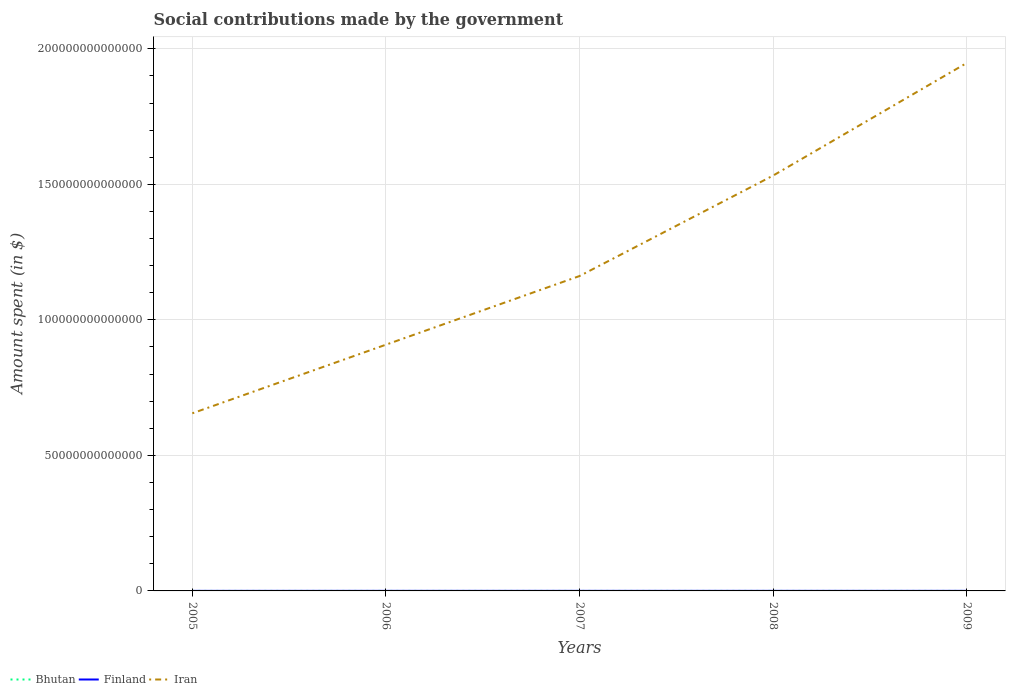Does the line corresponding to Finland intersect with the line corresponding to Iran?
Your answer should be very brief. No. Across all years, what is the maximum amount spent on social contributions in Bhutan?
Offer a very short reply. 3.60e+07. In which year was the amount spent on social contributions in Bhutan maximum?
Offer a very short reply. 2005. What is the total amount spent on social contributions in Bhutan in the graph?
Your answer should be compact. -2.72e+07. What is the difference between the highest and the second highest amount spent on social contributions in Bhutan?
Your response must be concise. 3.53e+07. What is the difference between the highest and the lowest amount spent on social contributions in Finland?
Ensure brevity in your answer.  3. How many lines are there?
Offer a terse response. 3. How many years are there in the graph?
Your answer should be compact. 5. What is the difference between two consecutive major ticks on the Y-axis?
Your answer should be very brief. 5.00e+13. Does the graph contain grids?
Your answer should be very brief. Yes. Where does the legend appear in the graph?
Provide a short and direct response. Bottom left. How are the legend labels stacked?
Make the answer very short. Horizontal. What is the title of the graph?
Make the answer very short. Social contributions made by the government. What is the label or title of the Y-axis?
Your answer should be very brief. Amount spent (in $). What is the Amount spent (in $) in Bhutan in 2005?
Ensure brevity in your answer.  3.60e+07. What is the Amount spent (in $) in Finland in 2005?
Keep it short and to the point. 1.91e+1. What is the Amount spent (in $) of Iran in 2005?
Make the answer very short. 6.55e+13. What is the Amount spent (in $) in Bhutan in 2006?
Give a very brief answer. 4.41e+07. What is the Amount spent (in $) of Finland in 2006?
Ensure brevity in your answer.  2.05e+1. What is the Amount spent (in $) of Iran in 2006?
Keep it short and to the point. 9.09e+13. What is the Amount spent (in $) in Bhutan in 2007?
Give a very brief answer. 4.94e+07. What is the Amount spent (in $) of Finland in 2007?
Keep it short and to the point. 2.16e+1. What is the Amount spent (in $) of Iran in 2007?
Your answer should be compact. 1.16e+14. What is the Amount spent (in $) in Bhutan in 2008?
Offer a very short reply. 5.82e+07. What is the Amount spent (in $) in Finland in 2008?
Give a very brief answer. 2.25e+1. What is the Amount spent (in $) in Iran in 2008?
Provide a short and direct response. 1.53e+14. What is the Amount spent (in $) of Bhutan in 2009?
Provide a succinct answer. 7.13e+07. What is the Amount spent (in $) in Finland in 2009?
Your response must be concise. 2.22e+1. What is the Amount spent (in $) of Iran in 2009?
Give a very brief answer. 1.95e+14. Across all years, what is the maximum Amount spent (in $) of Bhutan?
Provide a succinct answer. 7.13e+07. Across all years, what is the maximum Amount spent (in $) of Finland?
Offer a terse response. 2.25e+1. Across all years, what is the maximum Amount spent (in $) of Iran?
Your answer should be compact. 1.95e+14. Across all years, what is the minimum Amount spent (in $) in Bhutan?
Provide a succinct answer. 3.60e+07. Across all years, what is the minimum Amount spent (in $) in Finland?
Ensure brevity in your answer.  1.91e+1. Across all years, what is the minimum Amount spent (in $) in Iran?
Keep it short and to the point. 6.55e+13. What is the total Amount spent (in $) in Bhutan in the graph?
Your answer should be very brief. 2.59e+08. What is the total Amount spent (in $) in Finland in the graph?
Give a very brief answer. 1.06e+11. What is the total Amount spent (in $) of Iran in the graph?
Make the answer very short. 6.21e+14. What is the difference between the Amount spent (in $) of Bhutan in 2005 and that in 2006?
Provide a succinct answer. -8.06e+06. What is the difference between the Amount spent (in $) in Finland in 2005 and that in 2006?
Your answer should be very brief. -1.39e+09. What is the difference between the Amount spent (in $) of Iran in 2005 and that in 2006?
Your answer should be compact. -2.53e+13. What is the difference between the Amount spent (in $) of Bhutan in 2005 and that in 2007?
Keep it short and to the point. -1.34e+07. What is the difference between the Amount spent (in $) of Finland in 2005 and that in 2007?
Offer a terse response. -2.50e+09. What is the difference between the Amount spent (in $) in Iran in 2005 and that in 2007?
Offer a very short reply. -5.06e+13. What is the difference between the Amount spent (in $) in Bhutan in 2005 and that in 2008?
Your answer should be very brief. -2.22e+07. What is the difference between the Amount spent (in $) of Finland in 2005 and that in 2008?
Your answer should be compact. -3.45e+09. What is the difference between the Amount spent (in $) in Iran in 2005 and that in 2008?
Your response must be concise. -8.77e+13. What is the difference between the Amount spent (in $) of Bhutan in 2005 and that in 2009?
Make the answer very short. -3.53e+07. What is the difference between the Amount spent (in $) in Finland in 2005 and that in 2009?
Offer a very short reply. -3.15e+09. What is the difference between the Amount spent (in $) of Iran in 2005 and that in 2009?
Offer a terse response. -1.29e+14. What is the difference between the Amount spent (in $) of Bhutan in 2006 and that in 2007?
Your response must be concise. -5.36e+06. What is the difference between the Amount spent (in $) in Finland in 2006 and that in 2007?
Provide a succinct answer. -1.11e+09. What is the difference between the Amount spent (in $) in Iran in 2006 and that in 2007?
Provide a short and direct response. -2.53e+13. What is the difference between the Amount spent (in $) of Bhutan in 2006 and that in 2008?
Make the answer very short. -1.41e+07. What is the difference between the Amount spent (in $) in Finland in 2006 and that in 2008?
Offer a terse response. -2.05e+09. What is the difference between the Amount spent (in $) in Iran in 2006 and that in 2008?
Your answer should be very brief. -6.24e+13. What is the difference between the Amount spent (in $) in Bhutan in 2006 and that in 2009?
Provide a succinct answer. -2.72e+07. What is the difference between the Amount spent (in $) in Finland in 2006 and that in 2009?
Your answer should be very brief. -1.76e+09. What is the difference between the Amount spent (in $) of Iran in 2006 and that in 2009?
Make the answer very short. -1.04e+14. What is the difference between the Amount spent (in $) in Bhutan in 2007 and that in 2008?
Provide a succinct answer. -8.78e+06. What is the difference between the Amount spent (in $) of Finland in 2007 and that in 2008?
Keep it short and to the point. -9.45e+08. What is the difference between the Amount spent (in $) in Iran in 2007 and that in 2008?
Make the answer very short. -3.71e+13. What is the difference between the Amount spent (in $) in Bhutan in 2007 and that in 2009?
Provide a short and direct response. -2.19e+07. What is the difference between the Amount spent (in $) in Finland in 2007 and that in 2009?
Make the answer very short. -6.51e+08. What is the difference between the Amount spent (in $) of Iran in 2007 and that in 2009?
Provide a short and direct response. -7.86e+13. What is the difference between the Amount spent (in $) in Bhutan in 2008 and that in 2009?
Your response must be concise. -1.31e+07. What is the difference between the Amount spent (in $) in Finland in 2008 and that in 2009?
Provide a short and direct response. 2.94e+08. What is the difference between the Amount spent (in $) in Iran in 2008 and that in 2009?
Provide a short and direct response. -4.15e+13. What is the difference between the Amount spent (in $) of Bhutan in 2005 and the Amount spent (in $) of Finland in 2006?
Provide a short and direct response. -2.05e+1. What is the difference between the Amount spent (in $) of Bhutan in 2005 and the Amount spent (in $) of Iran in 2006?
Your answer should be compact. -9.09e+13. What is the difference between the Amount spent (in $) in Finland in 2005 and the Amount spent (in $) in Iran in 2006?
Provide a succinct answer. -9.08e+13. What is the difference between the Amount spent (in $) in Bhutan in 2005 and the Amount spent (in $) in Finland in 2007?
Your answer should be very brief. -2.16e+1. What is the difference between the Amount spent (in $) of Bhutan in 2005 and the Amount spent (in $) of Iran in 2007?
Your answer should be compact. -1.16e+14. What is the difference between the Amount spent (in $) in Finland in 2005 and the Amount spent (in $) in Iran in 2007?
Keep it short and to the point. -1.16e+14. What is the difference between the Amount spent (in $) in Bhutan in 2005 and the Amount spent (in $) in Finland in 2008?
Keep it short and to the point. -2.25e+1. What is the difference between the Amount spent (in $) in Bhutan in 2005 and the Amount spent (in $) in Iran in 2008?
Provide a short and direct response. -1.53e+14. What is the difference between the Amount spent (in $) of Finland in 2005 and the Amount spent (in $) of Iran in 2008?
Ensure brevity in your answer.  -1.53e+14. What is the difference between the Amount spent (in $) of Bhutan in 2005 and the Amount spent (in $) of Finland in 2009?
Offer a terse response. -2.22e+1. What is the difference between the Amount spent (in $) in Bhutan in 2005 and the Amount spent (in $) in Iran in 2009?
Ensure brevity in your answer.  -1.95e+14. What is the difference between the Amount spent (in $) of Finland in 2005 and the Amount spent (in $) of Iran in 2009?
Make the answer very short. -1.95e+14. What is the difference between the Amount spent (in $) of Bhutan in 2006 and the Amount spent (in $) of Finland in 2007?
Your answer should be very brief. -2.16e+1. What is the difference between the Amount spent (in $) in Bhutan in 2006 and the Amount spent (in $) in Iran in 2007?
Provide a succinct answer. -1.16e+14. What is the difference between the Amount spent (in $) of Finland in 2006 and the Amount spent (in $) of Iran in 2007?
Your answer should be compact. -1.16e+14. What is the difference between the Amount spent (in $) in Bhutan in 2006 and the Amount spent (in $) in Finland in 2008?
Offer a terse response. -2.25e+1. What is the difference between the Amount spent (in $) of Bhutan in 2006 and the Amount spent (in $) of Iran in 2008?
Offer a very short reply. -1.53e+14. What is the difference between the Amount spent (in $) in Finland in 2006 and the Amount spent (in $) in Iran in 2008?
Make the answer very short. -1.53e+14. What is the difference between the Amount spent (in $) of Bhutan in 2006 and the Amount spent (in $) of Finland in 2009?
Offer a terse response. -2.22e+1. What is the difference between the Amount spent (in $) in Bhutan in 2006 and the Amount spent (in $) in Iran in 2009?
Ensure brevity in your answer.  -1.95e+14. What is the difference between the Amount spent (in $) in Finland in 2006 and the Amount spent (in $) in Iran in 2009?
Provide a short and direct response. -1.95e+14. What is the difference between the Amount spent (in $) in Bhutan in 2007 and the Amount spent (in $) in Finland in 2008?
Make the answer very short. -2.25e+1. What is the difference between the Amount spent (in $) of Bhutan in 2007 and the Amount spent (in $) of Iran in 2008?
Offer a terse response. -1.53e+14. What is the difference between the Amount spent (in $) in Finland in 2007 and the Amount spent (in $) in Iran in 2008?
Your response must be concise. -1.53e+14. What is the difference between the Amount spent (in $) in Bhutan in 2007 and the Amount spent (in $) in Finland in 2009?
Provide a short and direct response. -2.22e+1. What is the difference between the Amount spent (in $) in Bhutan in 2007 and the Amount spent (in $) in Iran in 2009?
Offer a very short reply. -1.95e+14. What is the difference between the Amount spent (in $) of Finland in 2007 and the Amount spent (in $) of Iran in 2009?
Ensure brevity in your answer.  -1.95e+14. What is the difference between the Amount spent (in $) in Bhutan in 2008 and the Amount spent (in $) in Finland in 2009?
Keep it short and to the point. -2.22e+1. What is the difference between the Amount spent (in $) in Bhutan in 2008 and the Amount spent (in $) in Iran in 2009?
Provide a short and direct response. -1.95e+14. What is the difference between the Amount spent (in $) in Finland in 2008 and the Amount spent (in $) in Iran in 2009?
Make the answer very short. -1.95e+14. What is the average Amount spent (in $) in Bhutan per year?
Your answer should be very brief. 5.18e+07. What is the average Amount spent (in $) in Finland per year?
Your response must be concise. 2.12e+1. What is the average Amount spent (in $) in Iran per year?
Your answer should be compact. 1.24e+14. In the year 2005, what is the difference between the Amount spent (in $) in Bhutan and Amount spent (in $) in Finland?
Ensure brevity in your answer.  -1.91e+1. In the year 2005, what is the difference between the Amount spent (in $) of Bhutan and Amount spent (in $) of Iran?
Your response must be concise. -6.55e+13. In the year 2005, what is the difference between the Amount spent (in $) in Finland and Amount spent (in $) in Iran?
Your response must be concise. -6.55e+13. In the year 2006, what is the difference between the Amount spent (in $) in Bhutan and Amount spent (in $) in Finland?
Give a very brief answer. -2.04e+1. In the year 2006, what is the difference between the Amount spent (in $) of Bhutan and Amount spent (in $) of Iran?
Offer a very short reply. -9.09e+13. In the year 2006, what is the difference between the Amount spent (in $) of Finland and Amount spent (in $) of Iran?
Provide a short and direct response. -9.08e+13. In the year 2007, what is the difference between the Amount spent (in $) in Bhutan and Amount spent (in $) in Finland?
Give a very brief answer. -2.15e+1. In the year 2007, what is the difference between the Amount spent (in $) in Bhutan and Amount spent (in $) in Iran?
Provide a short and direct response. -1.16e+14. In the year 2007, what is the difference between the Amount spent (in $) of Finland and Amount spent (in $) of Iran?
Ensure brevity in your answer.  -1.16e+14. In the year 2008, what is the difference between the Amount spent (in $) in Bhutan and Amount spent (in $) in Finland?
Give a very brief answer. -2.25e+1. In the year 2008, what is the difference between the Amount spent (in $) of Bhutan and Amount spent (in $) of Iran?
Ensure brevity in your answer.  -1.53e+14. In the year 2008, what is the difference between the Amount spent (in $) in Finland and Amount spent (in $) in Iran?
Offer a very short reply. -1.53e+14. In the year 2009, what is the difference between the Amount spent (in $) in Bhutan and Amount spent (in $) in Finland?
Your answer should be compact. -2.22e+1. In the year 2009, what is the difference between the Amount spent (in $) of Bhutan and Amount spent (in $) of Iran?
Your answer should be compact. -1.95e+14. In the year 2009, what is the difference between the Amount spent (in $) in Finland and Amount spent (in $) in Iran?
Your response must be concise. -1.95e+14. What is the ratio of the Amount spent (in $) of Bhutan in 2005 to that in 2006?
Make the answer very short. 0.82. What is the ratio of the Amount spent (in $) of Finland in 2005 to that in 2006?
Ensure brevity in your answer.  0.93. What is the ratio of the Amount spent (in $) in Iran in 2005 to that in 2006?
Offer a terse response. 0.72. What is the ratio of the Amount spent (in $) of Bhutan in 2005 to that in 2007?
Your answer should be compact. 0.73. What is the ratio of the Amount spent (in $) of Finland in 2005 to that in 2007?
Your answer should be very brief. 0.88. What is the ratio of the Amount spent (in $) in Iran in 2005 to that in 2007?
Offer a very short reply. 0.56. What is the ratio of the Amount spent (in $) in Bhutan in 2005 to that in 2008?
Ensure brevity in your answer.  0.62. What is the ratio of the Amount spent (in $) of Finland in 2005 to that in 2008?
Offer a very short reply. 0.85. What is the ratio of the Amount spent (in $) in Iran in 2005 to that in 2008?
Keep it short and to the point. 0.43. What is the ratio of the Amount spent (in $) in Bhutan in 2005 to that in 2009?
Make the answer very short. 0.51. What is the ratio of the Amount spent (in $) in Finland in 2005 to that in 2009?
Your answer should be very brief. 0.86. What is the ratio of the Amount spent (in $) of Iran in 2005 to that in 2009?
Make the answer very short. 0.34. What is the ratio of the Amount spent (in $) in Bhutan in 2006 to that in 2007?
Give a very brief answer. 0.89. What is the ratio of the Amount spent (in $) of Finland in 2006 to that in 2007?
Provide a short and direct response. 0.95. What is the ratio of the Amount spent (in $) of Iran in 2006 to that in 2007?
Make the answer very short. 0.78. What is the ratio of the Amount spent (in $) of Bhutan in 2006 to that in 2008?
Your answer should be compact. 0.76. What is the ratio of the Amount spent (in $) of Finland in 2006 to that in 2008?
Ensure brevity in your answer.  0.91. What is the ratio of the Amount spent (in $) in Iran in 2006 to that in 2008?
Your answer should be very brief. 0.59. What is the ratio of the Amount spent (in $) in Bhutan in 2006 to that in 2009?
Provide a short and direct response. 0.62. What is the ratio of the Amount spent (in $) in Finland in 2006 to that in 2009?
Provide a short and direct response. 0.92. What is the ratio of the Amount spent (in $) in Iran in 2006 to that in 2009?
Keep it short and to the point. 0.47. What is the ratio of the Amount spent (in $) in Bhutan in 2007 to that in 2008?
Your response must be concise. 0.85. What is the ratio of the Amount spent (in $) of Finland in 2007 to that in 2008?
Ensure brevity in your answer.  0.96. What is the ratio of the Amount spent (in $) of Iran in 2007 to that in 2008?
Ensure brevity in your answer.  0.76. What is the ratio of the Amount spent (in $) in Bhutan in 2007 to that in 2009?
Your answer should be very brief. 0.69. What is the ratio of the Amount spent (in $) in Finland in 2007 to that in 2009?
Provide a short and direct response. 0.97. What is the ratio of the Amount spent (in $) of Iran in 2007 to that in 2009?
Make the answer very short. 0.6. What is the ratio of the Amount spent (in $) of Bhutan in 2008 to that in 2009?
Offer a terse response. 0.82. What is the ratio of the Amount spent (in $) in Finland in 2008 to that in 2009?
Offer a very short reply. 1.01. What is the ratio of the Amount spent (in $) of Iran in 2008 to that in 2009?
Provide a succinct answer. 0.79. What is the difference between the highest and the second highest Amount spent (in $) in Bhutan?
Offer a very short reply. 1.31e+07. What is the difference between the highest and the second highest Amount spent (in $) in Finland?
Give a very brief answer. 2.94e+08. What is the difference between the highest and the second highest Amount spent (in $) in Iran?
Provide a short and direct response. 4.15e+13. What is the difference between the highest and the lowest Amount spent (in $) in Bhutan?
Provide a succinct answer. 3.53e+07. What is the difference between the highest and the lowest Amount spent (in $) of Finland?
Offer a terse response. 3.45e+09. What is the difference between the highest and the lowest Amount spent (in $) of Iran?
Your response must be concise. 1.29e+14. 